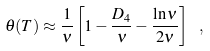<formula> <loc_0><loc_0><loc_500><loc_500>\theta ( T ) \approx \frac { 1 } { \nu } \left [ 1 - \frac { D _ { 4 } } { \nu } - \frac { \ln \nu } { 2 \nu } \right ] \ ,</formula> 